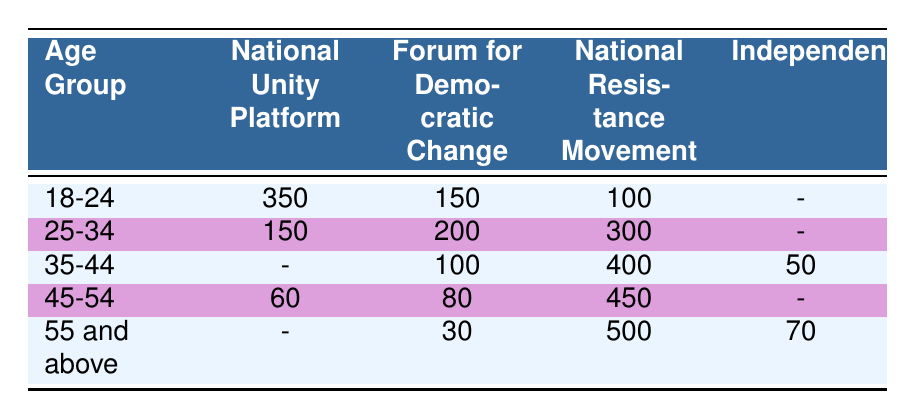What is the total number of votes for the National Unity Platform in the age group 18-24? The table shows that the National Unity Platform received 350 votes in the age group 18-24.
Answer: 350 Which party received the most votes in the age group 45-54? In the age group 45-54, the National Resistance Movement received the highest votes at 450, compared to 60 for the National Unity Platform and 80 for the Forum for Democratic Change.
Answer: National Resistance Movement Is the Forum for Democratic Change more preferred by the age group 35-44 or 25-34? The Forum for Democratic Change received 100 votes from the age group 35-44 and 200 votes from the age group 25-34. Since 200 is greater than 100, it is more preferred by the 25-34 age group.
Answer: 25-34 What is the combined total of votes for the National Resistance Movement across all age groups? To get the combined total, we add the votes: 100 (18-24) + 300 (25-34) + 400 (35-44) + 450 (45-54) + 500 (55 and above) = 2250 votes in total.
Answer: 2250 True or False: The Independent party received votes in the age group 18-24. The Independent party has a dash (-) in the age group 18-24, indicating that there were no votes for this party in that age group. Therefore, the statement is false.
Answer: False Which age group has the highest total votes for the National Resistance Movement? The total votes for the National Resistance Movement in each age group: 100 (18-24), 300 (25-34), 400 (35-44), 450 (45-54), and 500 (55 and above). The highest number is 500 votes for the age group 55 and above.
Answer: 55 and above What is the average number of votes received by the Forum for Democratic Change across all age groups? The Forum for Democratic Change received votes from four age groups: 150 (18-24), 200 (25-34), 100 (35-44), and 80 (45-54), totaling 530 votes. To find the average, divide by 4: 530 / 4 = 132.5.
Answer: 132.5 In which age group does the National Unity Platform have the least number of votes? The table shows that in the age group 45-54, the National Unity Platform received 60 votes, which is the least compared to 350 in 18-24, 150 in 25-34, and no votes in 35-44 and 55 and above.
Answer: 45-54 